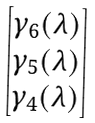<formula> <loc_0><loc_0><loc_500><loc_500>\begin{bmatrix} \gamma _ { 6 } ( \lambda ) \\ \gamma _ { 5 } ( \lambda ) \\ \gamma _ { 4 } ( \lambda ) \end{bmatrix}</formula> 